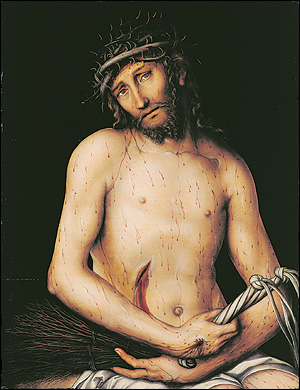What are the key elements in this picture? The painting is a poignant portrayal of Jesus Christ, marked by its somber palette, save for the stark contrast of Christ's pale skin against the dark backdrop. Highlighted by a crown of thorns, the artwork captures a moment of profound anguish and somber reflection. This piece is a masterful representation of religious art, likely reflecting on themes of sacrifice and redemption. The painter employs a realistic style, using light and shadows to intensify the emotional depth, drawing attention to the painful expressions and the meticulous details of Christ's physical suffering. 